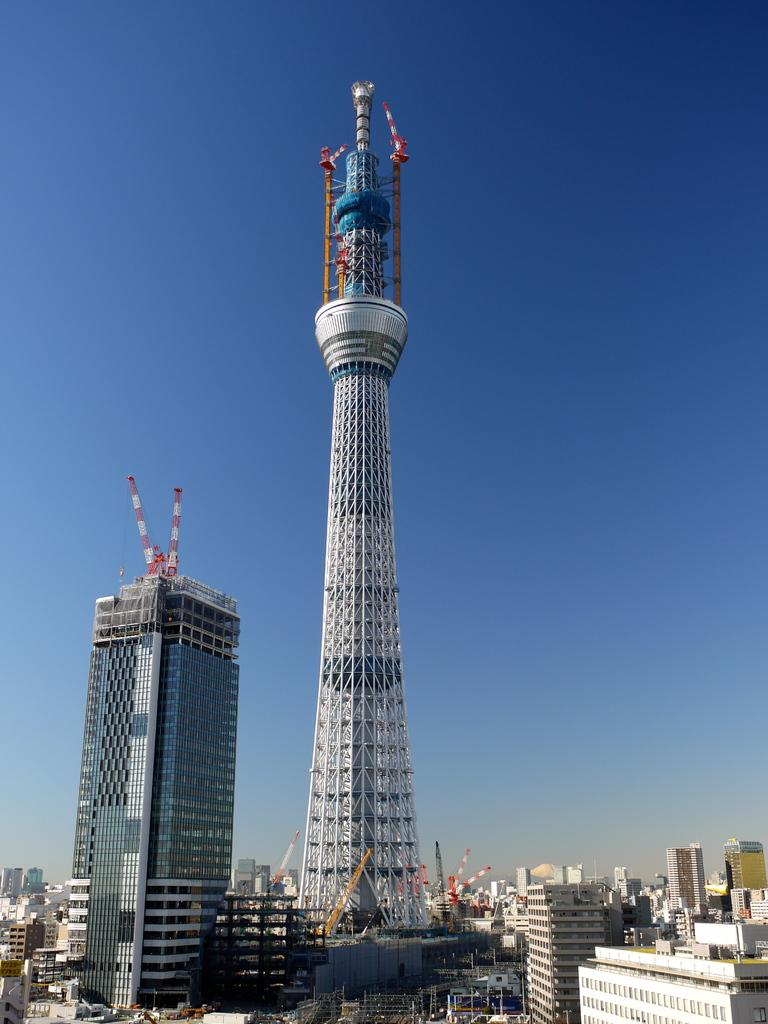What type of structures are visible in the image? There are skyscrapers and buildings in the image. What can be seen at the top of the buildings? Tower cranes are present at the top of the buildings. What is visible in the background of the image? The sky is visible in the image. Can you see a comb being used by the scarecrow in the image? There is no scarecrow or comb present in the image. 